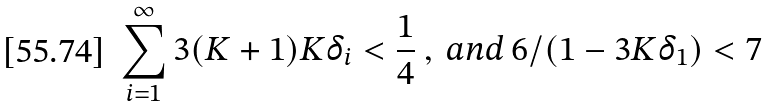Convert formula to latex. <formula><loc_0><loc_0><loc_500><loc_500>\sum _ { i = 1 } ^ { \infty } 3 ( K + 1 ) K \delta _ { i } < \frac { 1 } { 4 } \ , \text { and } 6 / ( 1 - 3 K \delta _ { 1 } ) < 7</formula> 